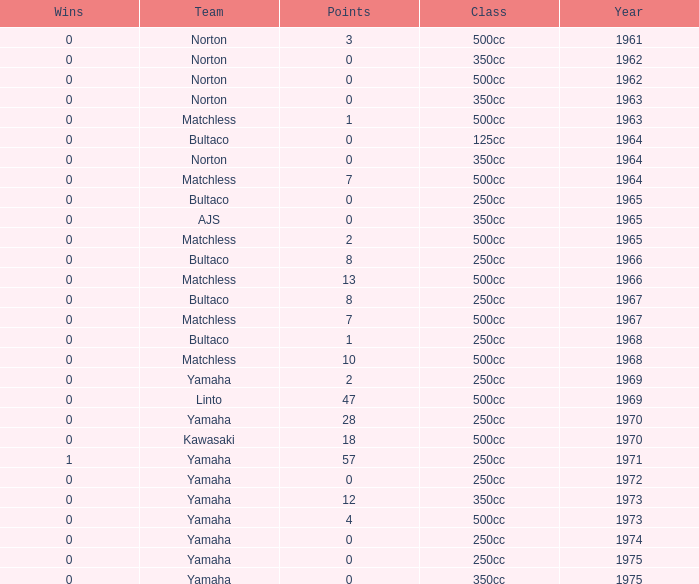What is the sum of all points in 1975 with 0 wins? None. 